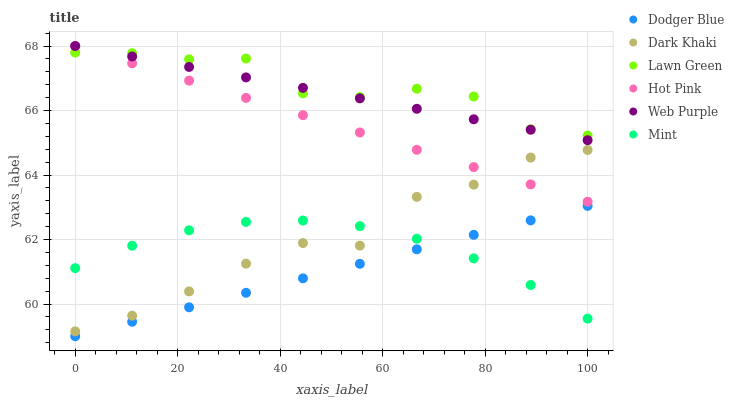Does Dodger Blue have the minimum area under the curve?
Answer yes or no. Yes. Does Lawn Green have the maximum area under the curve?
Answer yes or no. Yes. Does Hot Pink have the minimum area under the curve?
Answer yes or no. No. Does Hot Pink have the maximum area under the curve?
Answer yes or no. No. Is Dodger Blue the smoothest?
Answer yes or no. Yes. Is Dark Khaki the roughest?
Answer yes or no. Yes. Is Hot Pink the smoothest?
Answer yes or no. No. Is Hot Pink the roughest?
Answer yes or no. No. Does Dodger Blue have the lowest value?
Answer yes or no. Yes. Does Hot Pink have the lowest value?
Answer yes or no. No. Does Web Purple have the highest value?
Answer yes or no. Yes. Does Dark Khaki have the highest value?
Answer yes or no. No. Is Dodger Blue less than Lawn Green?
Answer yes or no. Yes. Is Web Purple greater than Dark Khaki?
Answer yes or no. Yes. Does Dark Khaki intersect Hot Pink?
Answer yes or no. Yes. Is Dark Khaki less than Hot Pink?
Answer yes or no. No. Is Dark Khaki greater than Hot Pink?
Answer yes or no. No. Does Dodger Blue intersect Lawn Green?
Answer yes or no. No. 